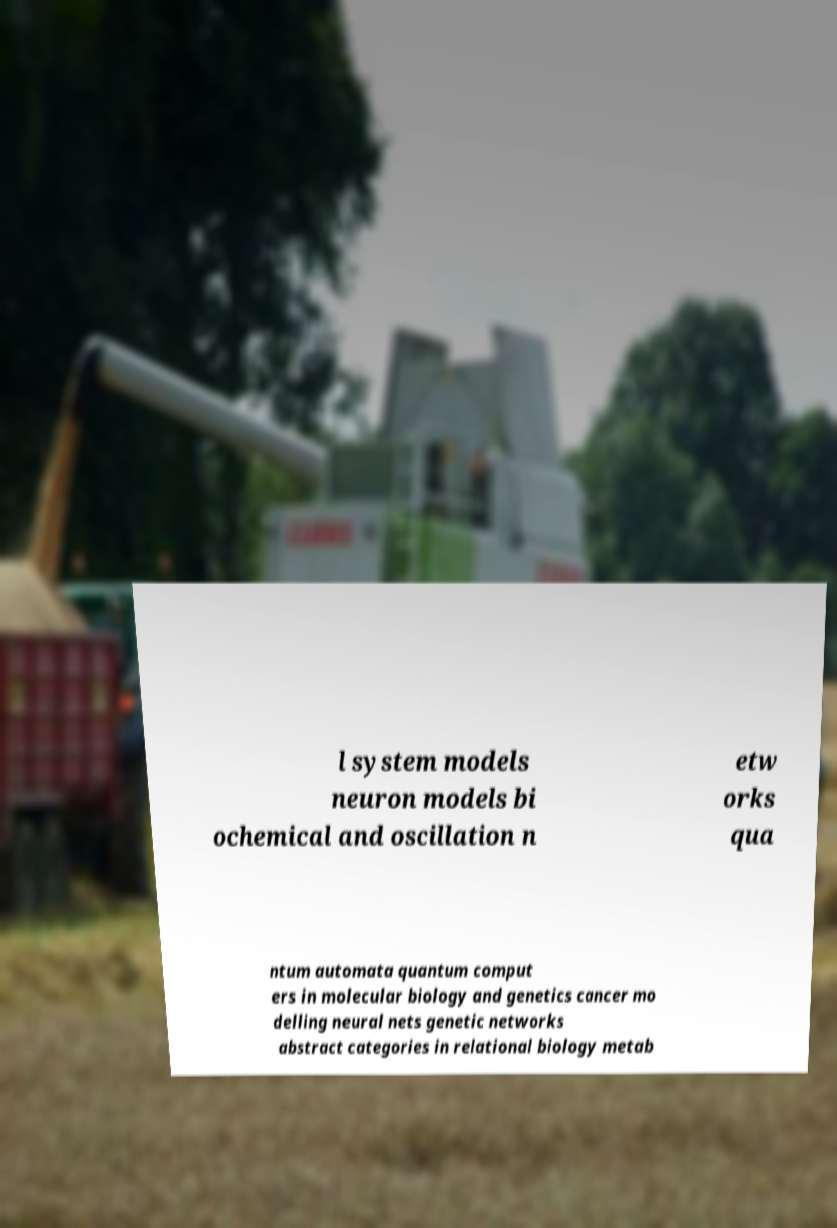For documentation purposes, I need the text within this image transcribed. Could you provide that? l system models neuron models bi ochemical and oscillation n etw orks qua ntum automata quantum comput ers in molecular biology and genetics cancer mo delling neural nets genetic networks abstract categories in relational biology metab 